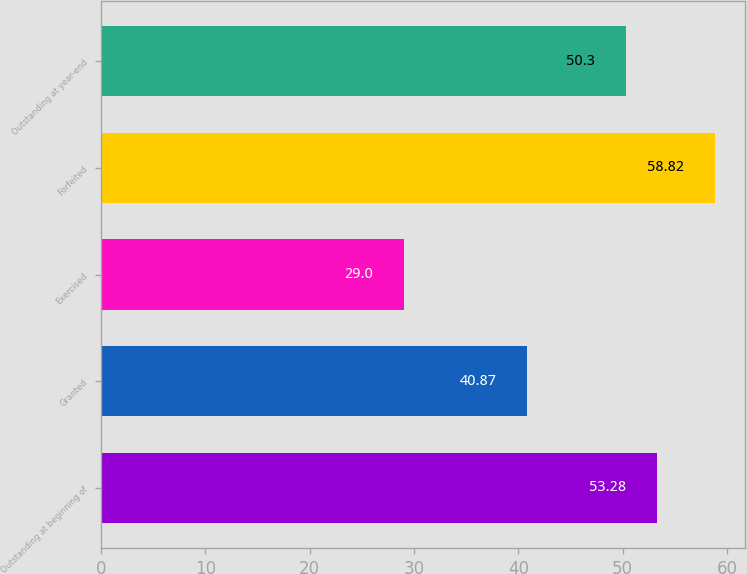Convert chart. <chart><loc_0><loc_0><loc_500><loc_500><bar_chart><fcel>Outstanding at beginning of<fcel>Granted<fcel>Exercised<fcel>Forfeited<fcel>Outstanding at year-end<nl><fcel>53.28<fcel>40.87<fcel>29<fcel>58.82<fcel>50.3<nl></chart> 